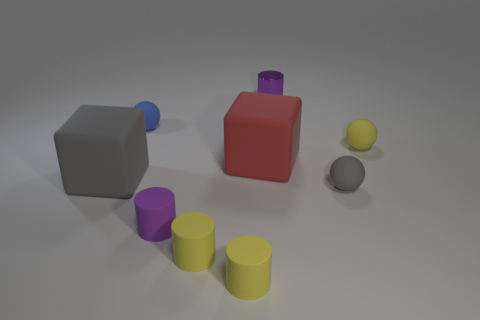There is another cylinder that is the same color as the tiny shiny cylinder; what is its material?
Keep it short and to the point. Rubber. Does the red cube have the same size as the purple matte cylinder?
Provide a short and direct response. No. There is a gray rubber thing to the left of the gray ball; are there any matte spheres left of it?
Ensure brevity in your answer.  No. What is the size of the matte object that is the same color as the metallic thing?
Ensure brevity in your answer.  Small. There is a small purple object that is in front of the tiny gray sphere; what is its shape?
Provide a short and direct response. Cylinder. What number of small yellow spheres are on the left side of the large block that is on the left side of the matte ball on the left side of the small gray object?
Offer a very short reply. 0. Is the size of the gray ball the same as the gray object that is left of the small gray matte thing?
Your response must be concise. No. There is a rubber thing that is left of the tiny blue thing behind the small gray rubber thing; what size is it?
Offer a very short reply. Large. How many yellow balls are made of the same material as the small blue sphere?
Make the answer very short. 1. Are any brown shiny things visible?
Give a very brief answer. No. 